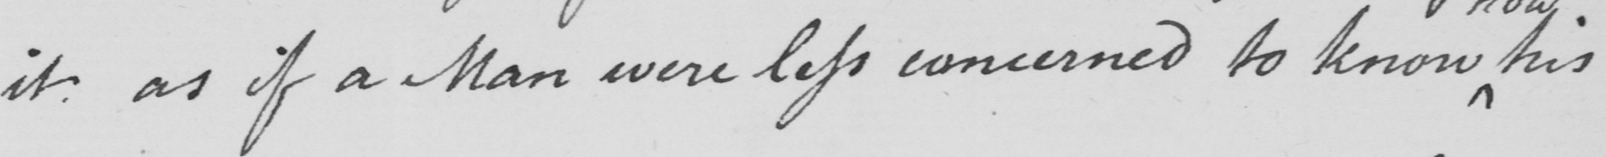Can you read and transcribe this handwriting? it as if a Man were less concerned to know his 